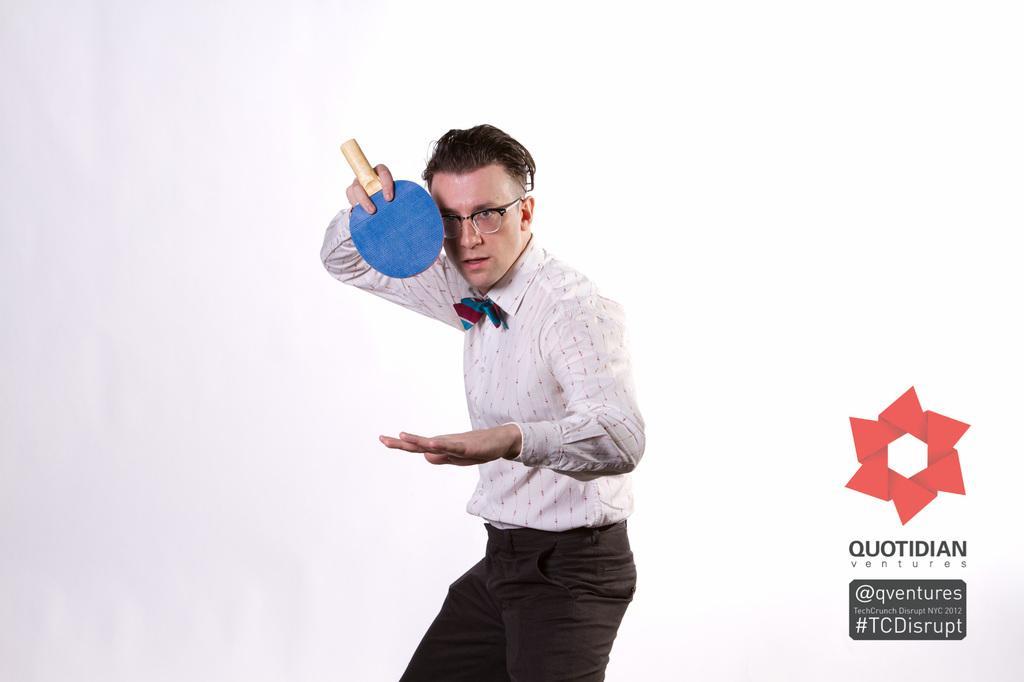Describe this image in one or two sentences. In this picture we can see man wore white color shirt with ribbon on it, spectacle holding table tennis bat and this is some poster. 